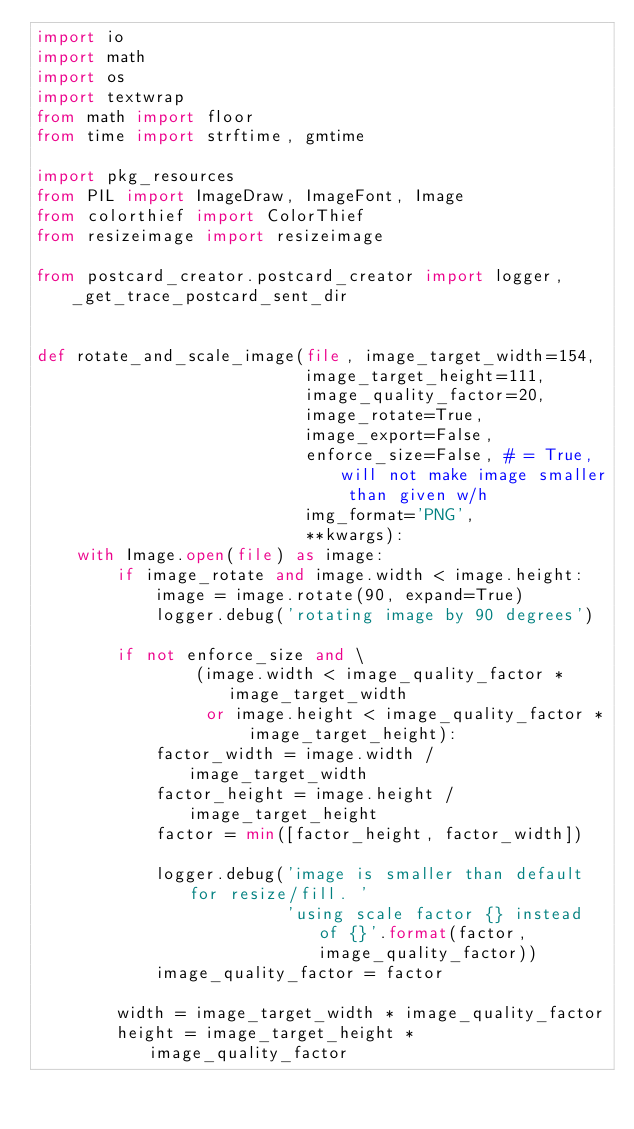<code> <loc_0><loc_0><loc_500><loc_500><_Python_>import io
import math
import os
import textwrap
from math import floor
from time import strftime, gmtime

import pkg_resources
from PIL import ImageDraw, ImageFont, Image
from colorthief import ColorThief
from resizeimage import resizeimage

from postcard_creator.postcard_creator import logger, _get_trace_postcard_sent_dir


def rotate_and_scale_image(file, image_target_width=154,
                           image_target_height=111,
                           image_quality_factor=20,
                           image_rotate=True,
                           image_export=False,
                           enforce_size=False, # = True, will not make image smaller than given w/h
                           img_format='PNG',
                           **kwargs):
    with Image.open(file) as image:
        if image_rotate and image.width < image.height:
            image = image.rotate(90, expand=True)
            logger.debug('rotating image by 90 degrees')

        if not enforce_size and \
                (image.width < image_quality_factor * image_target_width
                 or image.height < image_quality_factor * image_target_height):
            factor_width = image.width / image_target_width
            factor_height = image.height / image_target_height
            factor = min([factor_height, factor_width])

            logger.debug('image is smaller than default for resize/fill. '
                         'using scale factor {} instead of {}'.format(factor, image_quality_factor))
            image_quality_factor = factor

        width = image_target_width * image_quality_factor
        height = image_target_height * image_quality_factor</code> 